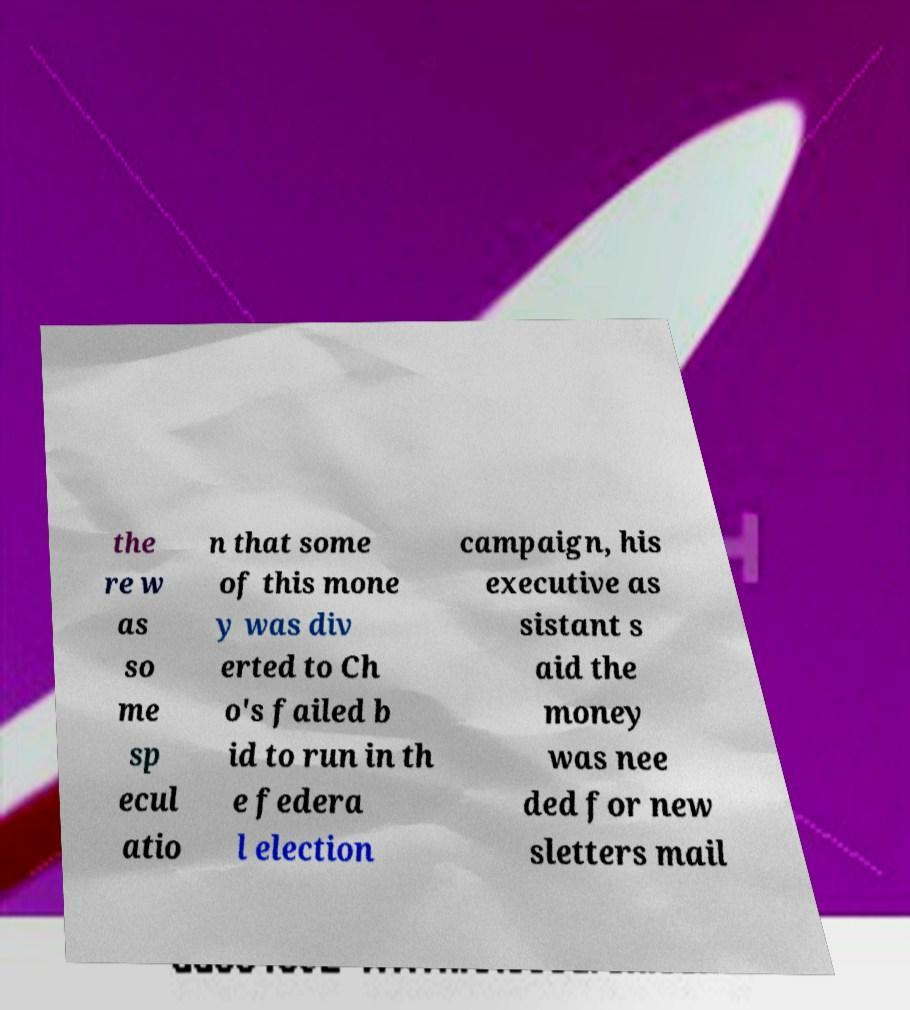Could you assist in decoding the text presented in this image and type it out clearly? the re w as so me sp ecul atio n that some of this mone y was div erted to Ch o's failed b id to run in th e federa l election campaign, his executive as sistant s aid the money was nee ded for new sletters mail 